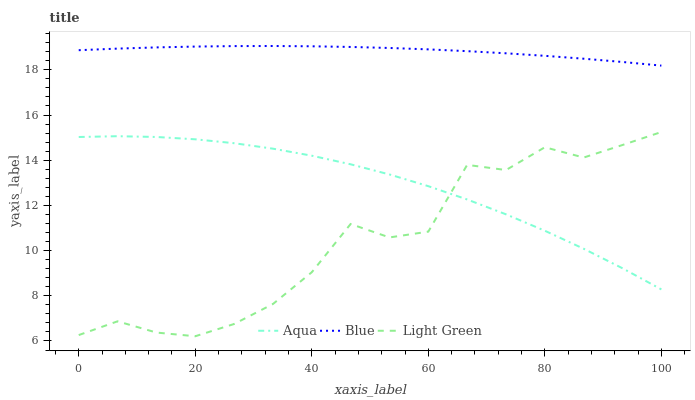Does Light Green have the minimum area under the curve?
Answer yes or no. Yes. Does Blue have the maximum area under the curve?
Answer yes or no. Yes. Does Aqua have the minimum area under the curve?
Answer yes or no. No. Does Aqua have the maximum area under the curve?
Answer yes or no. No. Is Blue the smoothest?
Answer yes or no. Yes. Is Light Green the roughest?
Answer yes or no. Yes. Is Aqua the smoothest?
Answer yes or no. No. Is Aqua the roughest?
Answer yes or no. No. Does Light Green have the lowest value?
Answer yes or no. Yes. Does Aqua have the lowest value?
Answer yes or no. No. Does Blue have the highest value?
Answer yes or no. Yes. Does Light Green have the highest value?
Answer yes or no. No. Is Aqua less than Blue?
Answer yes or no. Yes. Is Blue greater than Aqua?
Answer yes or no. Yes. Does Aqua intersect Light Green?
Answer yes or no. Yes. Is Aqua less than Light Green?
Answer yes or no. No. Is Aqua greater than Light Green?
Answer yes or no. No. Does Aqua intersect Blue?
Answer yes or no. No. 